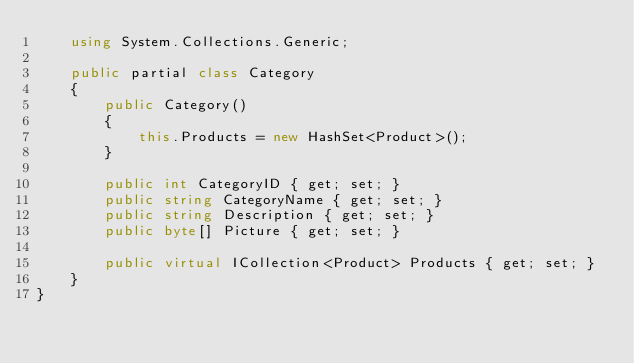<code> <loc_0><loc_0><loc_500><loc_500><_C#_>    using System.Collections.Generic;
    
    public partial class Category
    {
        public Category()
        {
            this.Products = new HashSet<Product>();
        }
    
        public int CategoryID { get; set; }
        public string CategoryName { get; set; }
        public string Description { get; set; }
        public byte[] Picture { get; set; }
    
        public virtual ICollection<Product> Products { get; set; }
    }
}
</code> 